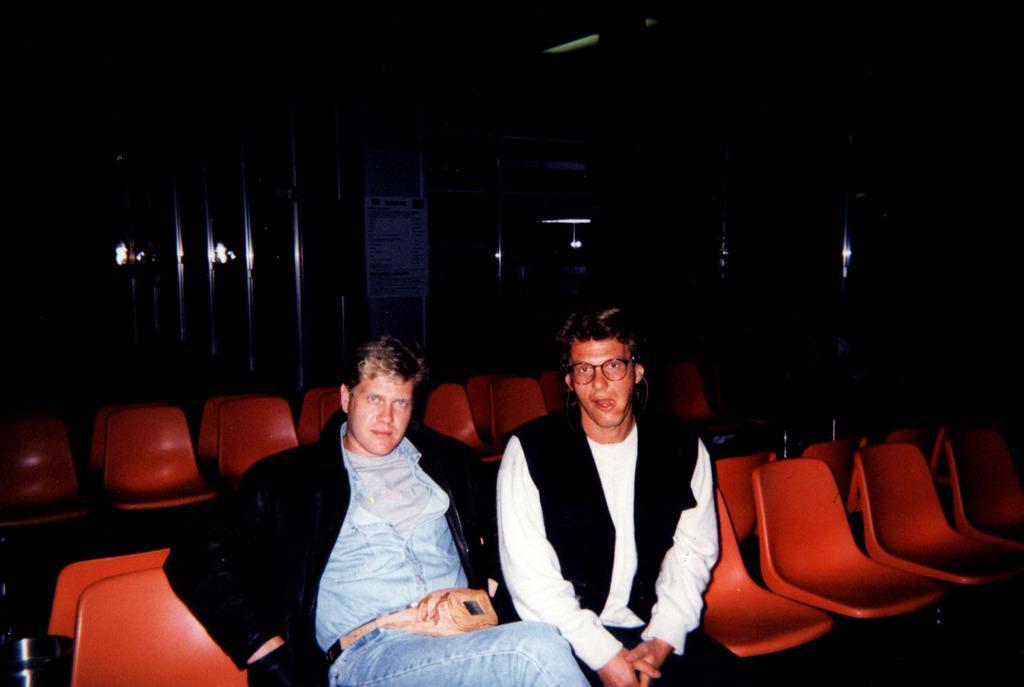Describe this image in one or two sentences. In this image I can see two persons sitting, the person at right is wearing black blazer and white color shirt. The person at left is wearing black and blue color dress and I can also see chairs in red color and I can see the dark background. 